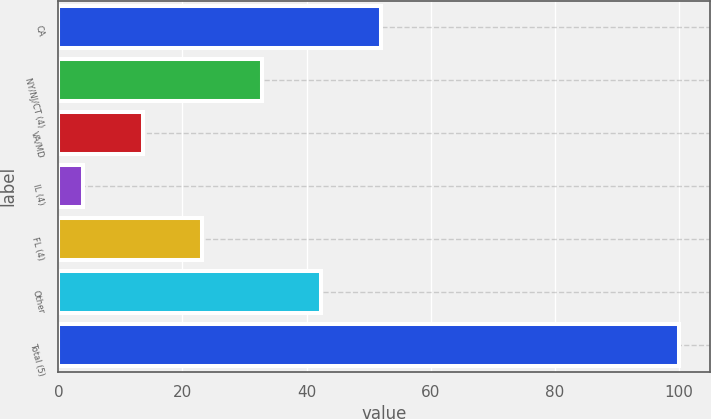Convert chart to OTSL. <chart><loc_0><loc_0><loc_500><loc_500><bar_chart><fcel>CA<fcel>NY/NJ/CT (4)<fcel>VA/MD<fcel>IL (4)<fcel>FL (4)<fcel>Other<fcel>Total (5)<nl><fcel>52<fcel>32.8<fcel>13.6<fcel>4<fcel>23.2<fcel>42.4<fcel>100<nl></chart> 